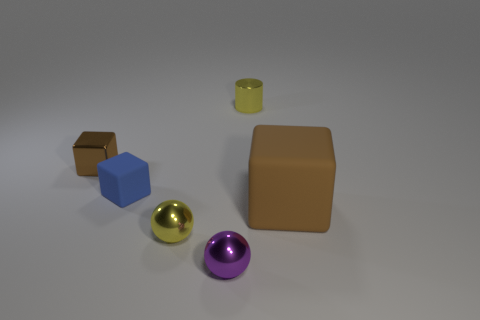How many objects are tiny yellow metal things behind the brown rubber block or cyan metal cubes? 1 